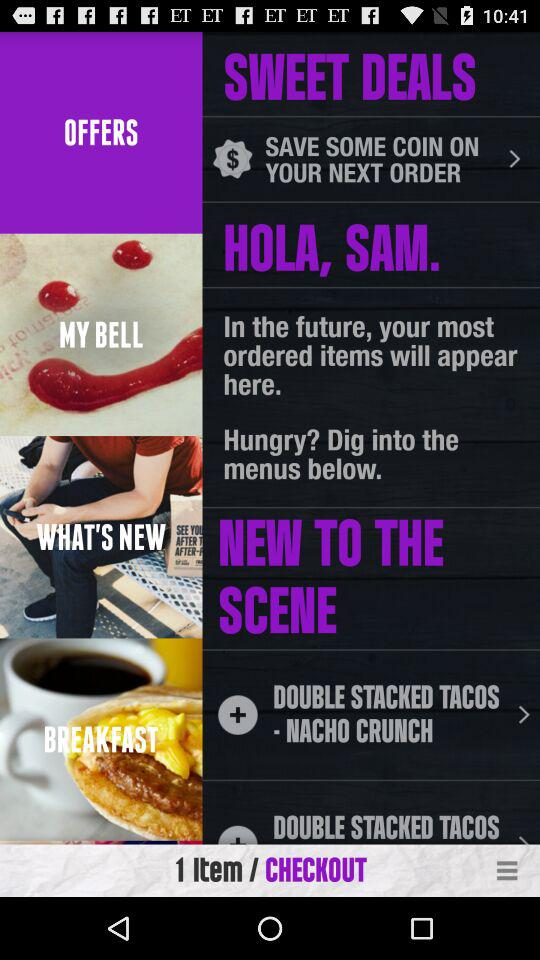How many items are in the cart?
Answer the question using a single word or phrase. 1 